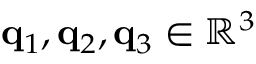<formula> <loc_0><loc_0><loc_500><loc_500>q _ { 1 } , q _ { 2 } , q _ { 3 } \in \mathbb { R } ^ { 3 }</formula> 